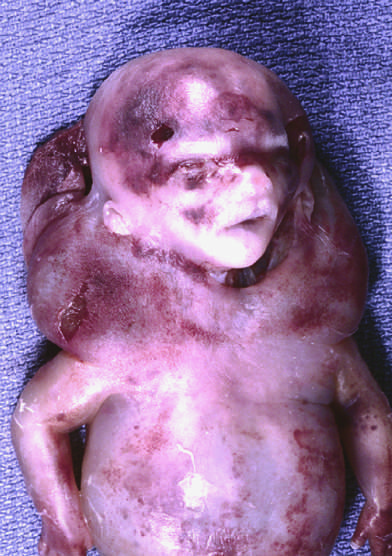what are characteristically seen with, but not limited to, constitutional chromosomal anomalies such as 45, x karyotypes?
Answer the question using a single word or phrase. Cystic hygromas 